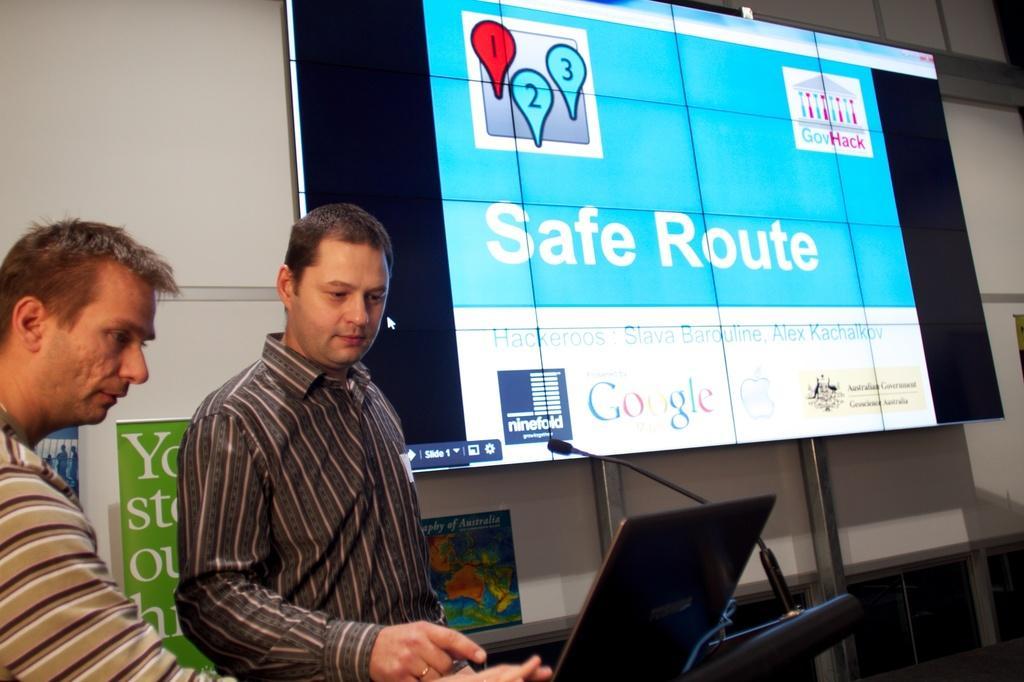Can you describe this image briefly? In-front of this wall there is a screen. Here we can see people. Backside of these people there is a map and hoardings. On this podium there is a mic and laptop.  